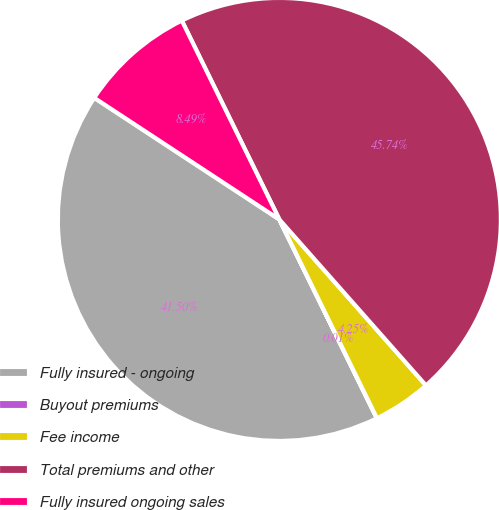Convert chart to OTSL. <chart><loc_0><loc_0><loc_500><loc_500><pie_chart><fcel>Fully insured - ongoing<fcel>Buyout premiums<fcel>Fee income<fcel>Total premiums and other<fcel>Fully insured ongoing sales<nl><fcel>41.5%<fcel>0.01%<fcel>4.25%<fcel>45.74%<fcel>8.49%<nl></chart> 